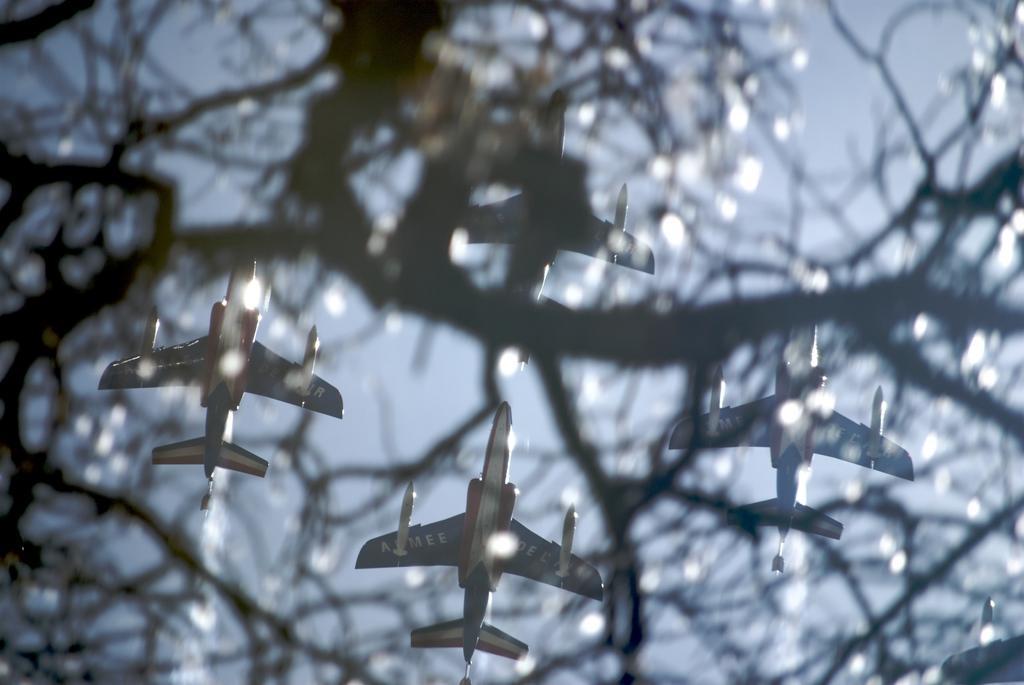Please provide a concise description of this image. In the foreground of this image, there is a tree. In the background, there are jet planes moving in the air and there is also the sky. 